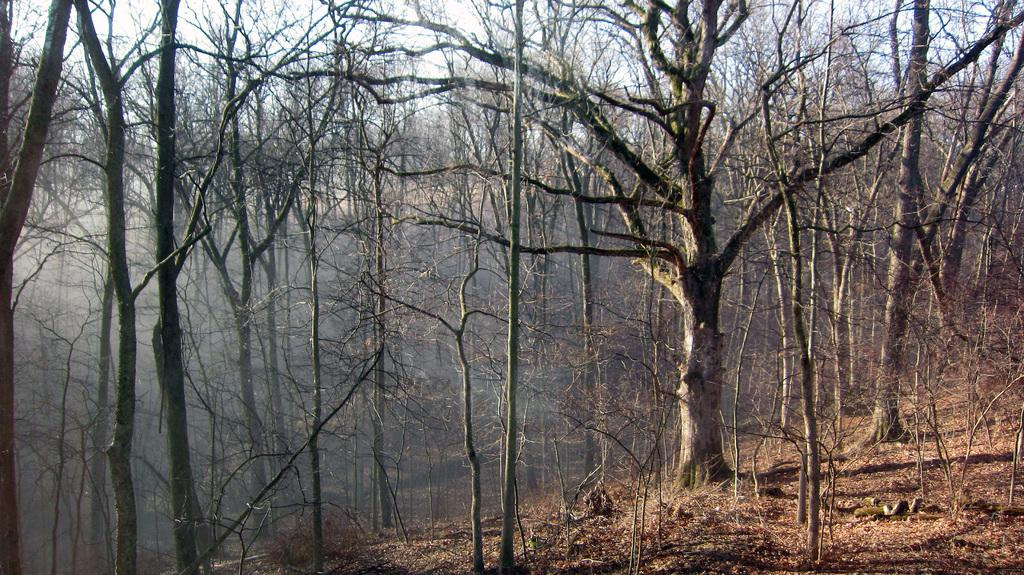What type of vegetation can be seen in the image? There are trees and plants in the image. Can you describe the plants in the image? The plants in the image are not specified, but they are present alongside the trees. What type of thread is being used to create a boundary in the image? There is no thread or boundary present in the image; it features trees and plants. 